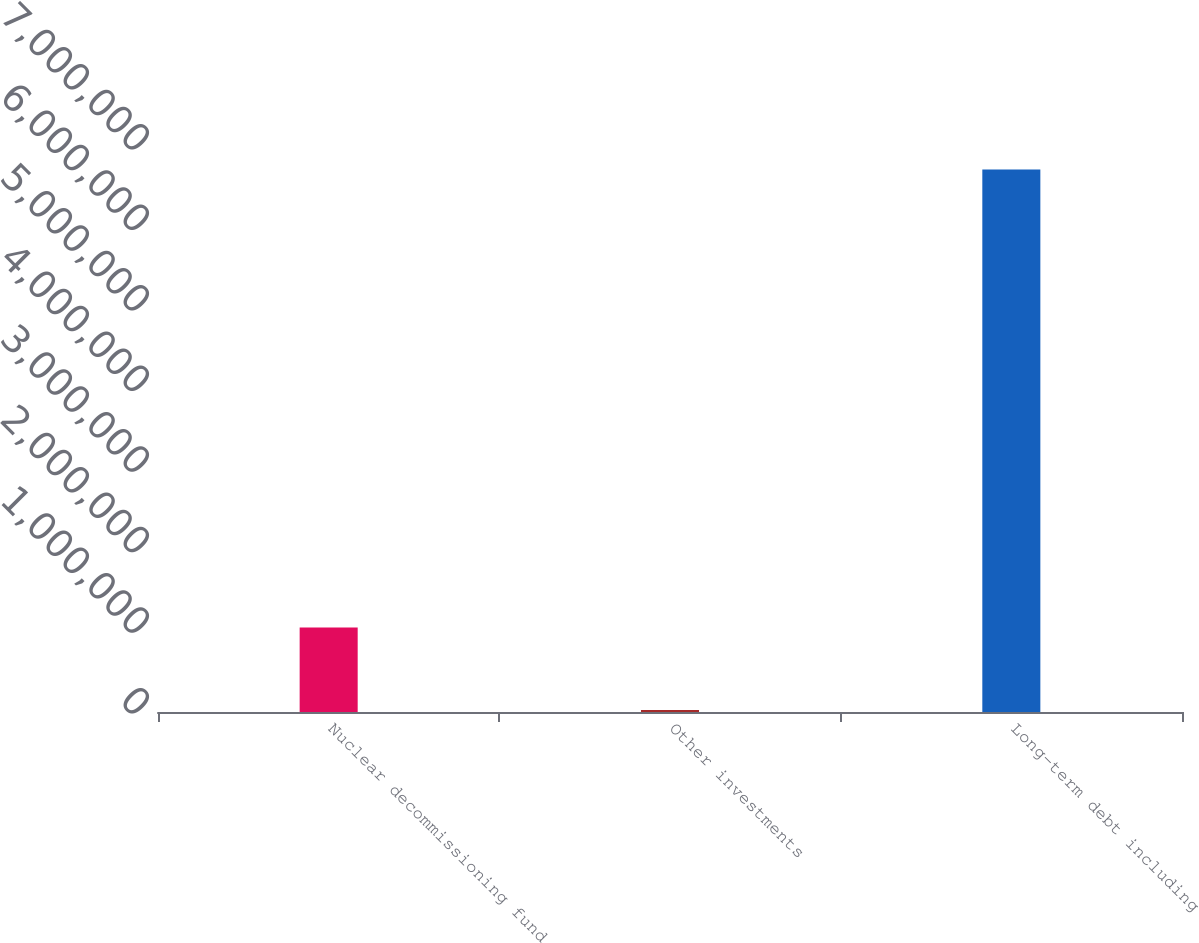Convert chart to OTSL. <chart><loc_0><loc_0><loc_500><loc_500><bar_chart><fcel>Nuclear decommissioning fund<fcel>Other investments<fcel>Long-term debt including<nl><fcel>1.04759e+06<fcel>24286<fcel>6.73328e+06<nl></chart> 